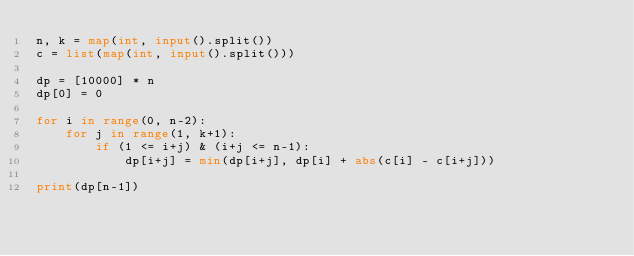<code> <loc_0><loc_0><loc_500><loc_500><_Python_>n, k = map(int, input().split())
c = list(map(int, input().split()))

dp = [10000] * n
dp[0] = 0

for i in range(0, n-2):
    for j in range(1, k+1):
        if (1 <= i+j) & (i+j <= n-1):
            dp[i+j] = min(dp[i+j], dp[i] + abs(c[i] - c[i+j]))

print(dp[n-1])</code> 